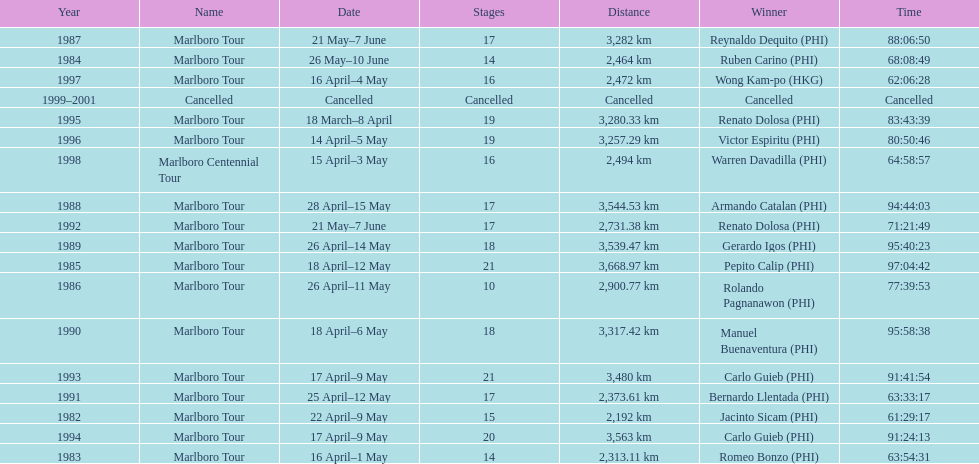How many stages was the 1982 marlboro tour? 15. 